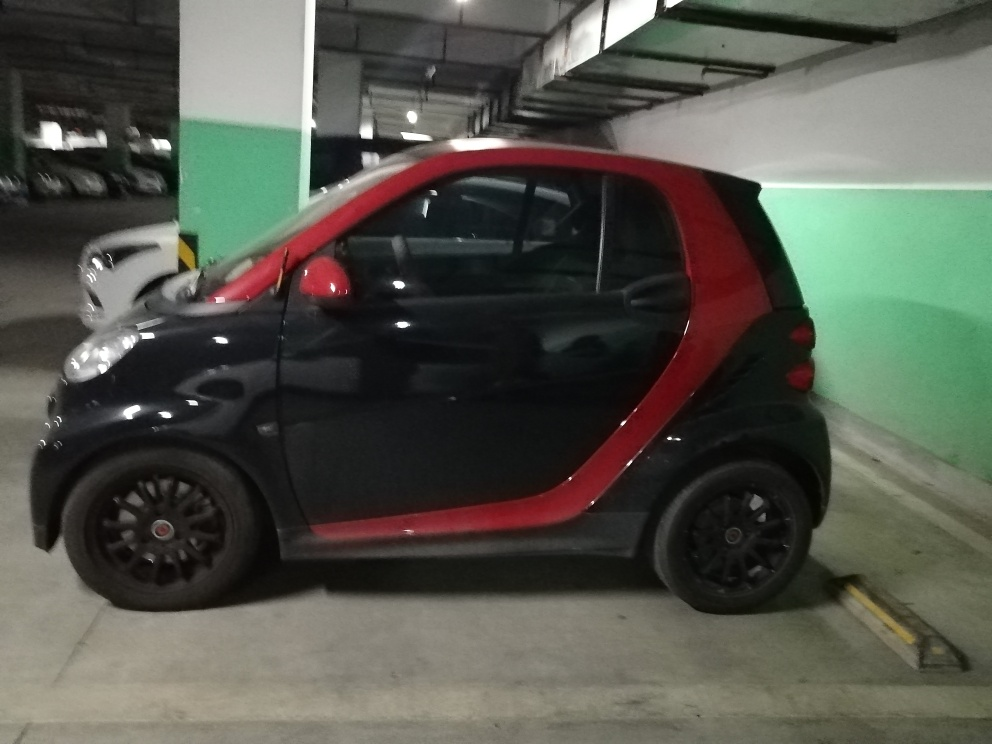Can you describe the car in the image? Certainly! The car is a small, two-seater vehicle with a compact design, ideal for urban environments. It has a black body with a contrasting red color on the sides and rear. The wheels are fitted with black rims that complement its sporty aesthetic. Is there anything you can tell about the location where it's parked? The car is parked in an indoor parking garage, indicated by the presence of overhead fluorescent lighting, painted pillars, and concrete flooring. The green walls are a distinct feature, suggesting a color-coded system which might be used to help people remember where they've parked. 